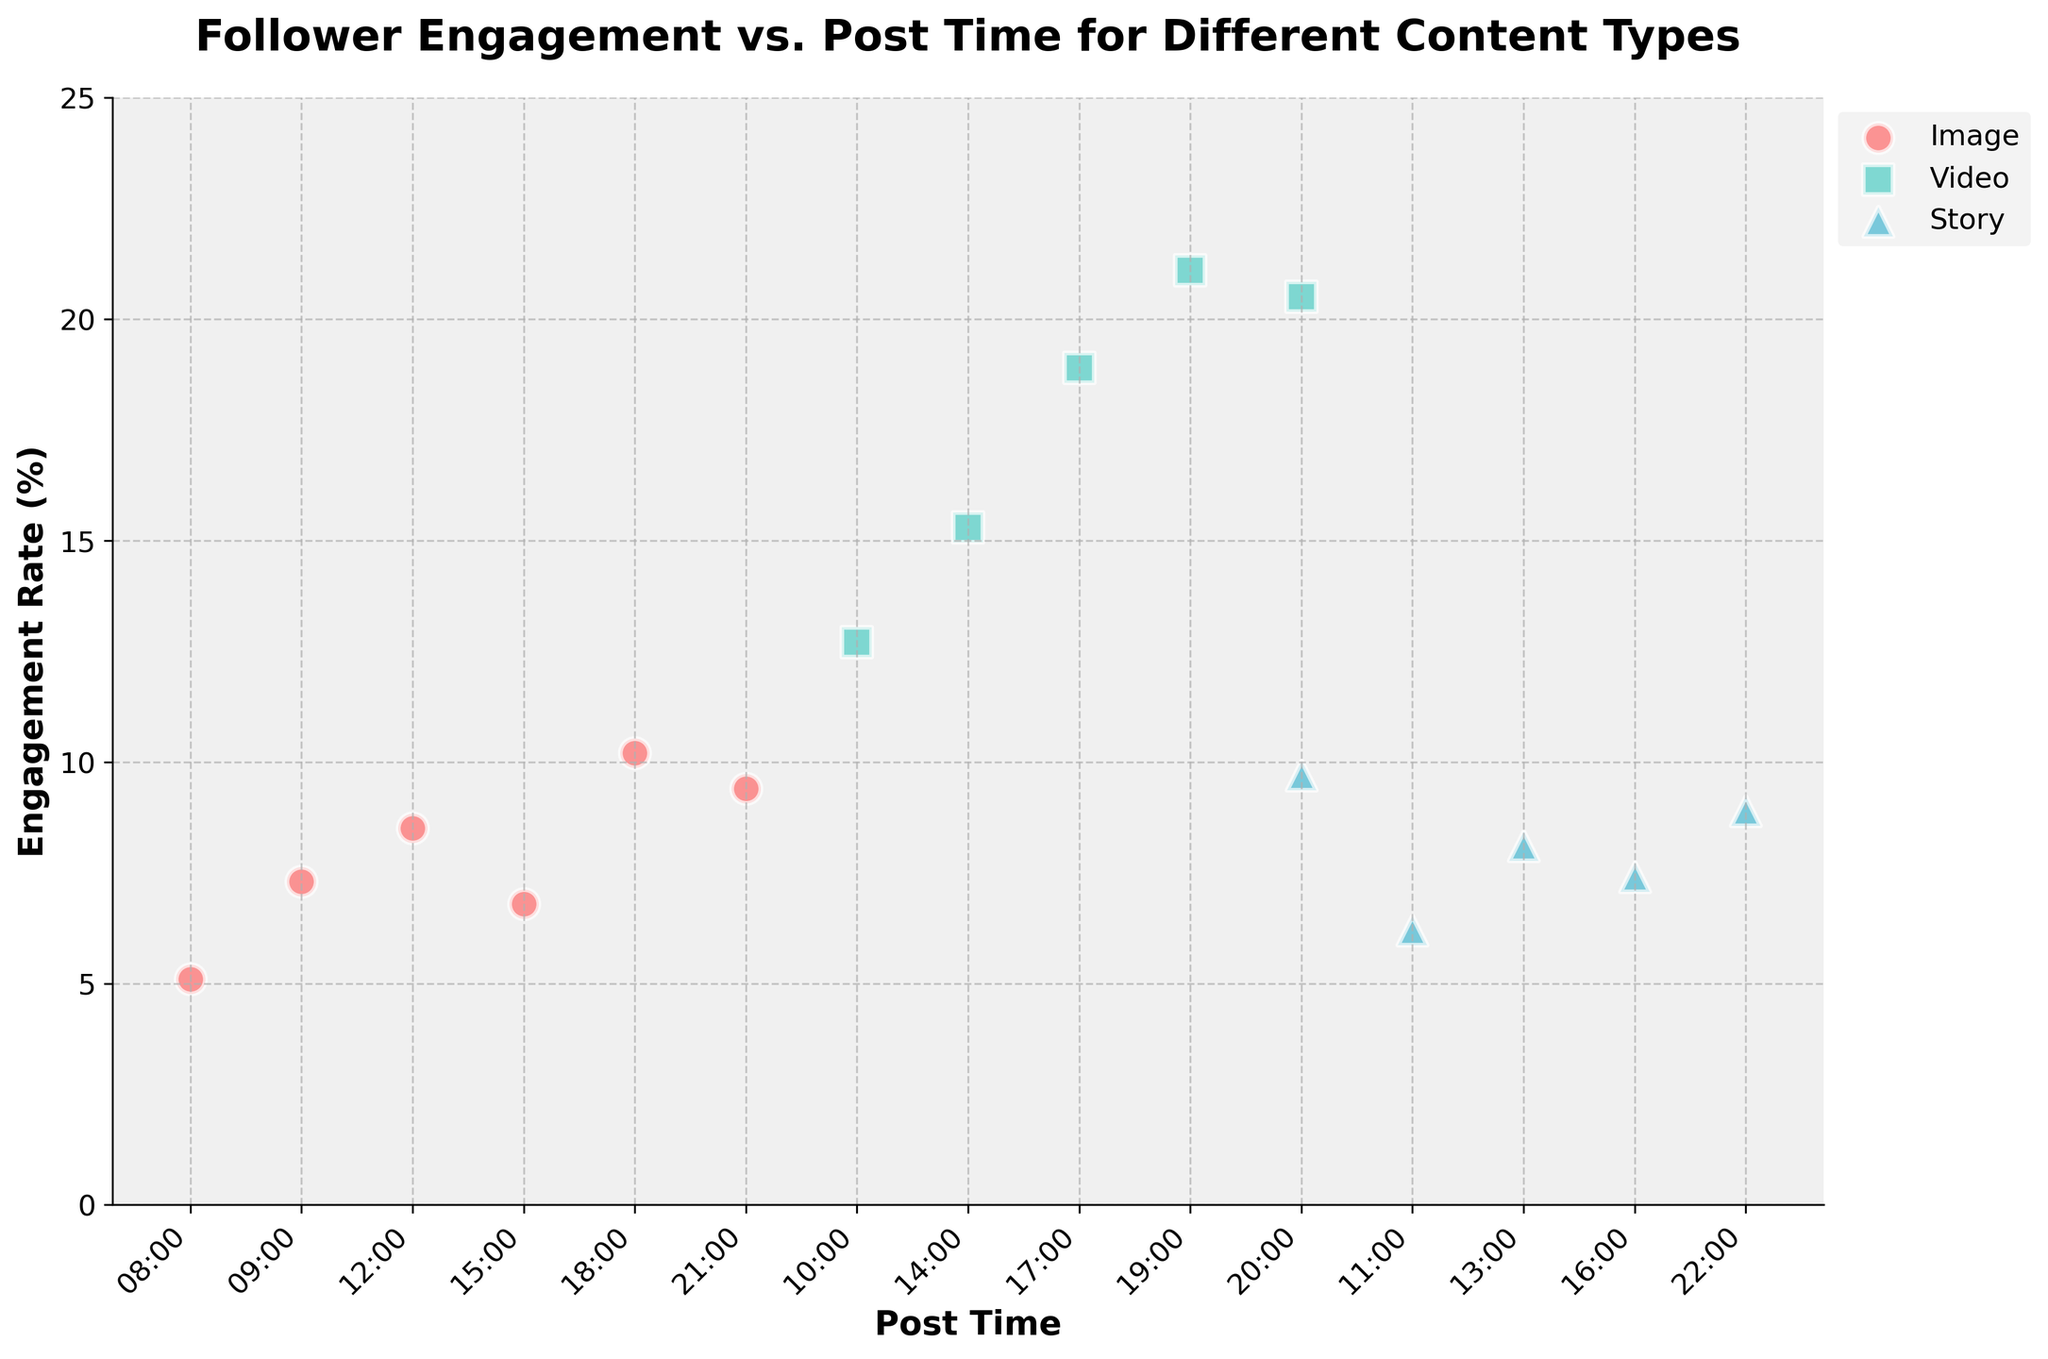what's the title of the figure? The title of the figure is displayed at the top and provides a summary of the content presented.
Answer: Follower Engagement vs. Post Time for Different Content Types what are the labels of the X-axis and Y-axis? The labels of the X-axis and Y-axis describe what each axis represents. The X-axis represents post time, and the Y-axis represents engagement rate.
Answer: Post Time and Engagement Rate (%) how many content types are displayed in the figure? The legend in the figure indicates the different content types plotted. There are three types: Image, Video, and Story.
Answer: Three at what time is the engagement rate for videos the highest? By looking at the video data points (marked with squares), the highest engagement rate is at 19:00.
Answer: 19:00 compare the engagement rates for images and stories at 20:00. Which one is higher? By checking the data points for both types at 20:00, the engagement rate for videos is higher (20.5 for Video vs. 9.7 for Story).
Answer: Video what is the engagement rate of images at 18:00? The engagement rate corresponding to the image content type at 18:00 is shown on the plot.
Answer: 10.2 what is the average engagement rate for stories? Sum the engagement rates for all Story data points and divide by the number of data points (6.2 + 8.1 + 7.4 + 9.7 + 8.9) / 5.
Answer: 8.06 which content type shows the most distinct increase in engagement rate over the day? By observing the trends over different times, videos show a significant increase in engagement rate from 10:00 to 20:00.
Answer: Video At what times both Stories and Images have data points? Common times can be determined by matching time points when both Stories and Images have engagement rates plotted at 20:00.
Answer: 20:00 